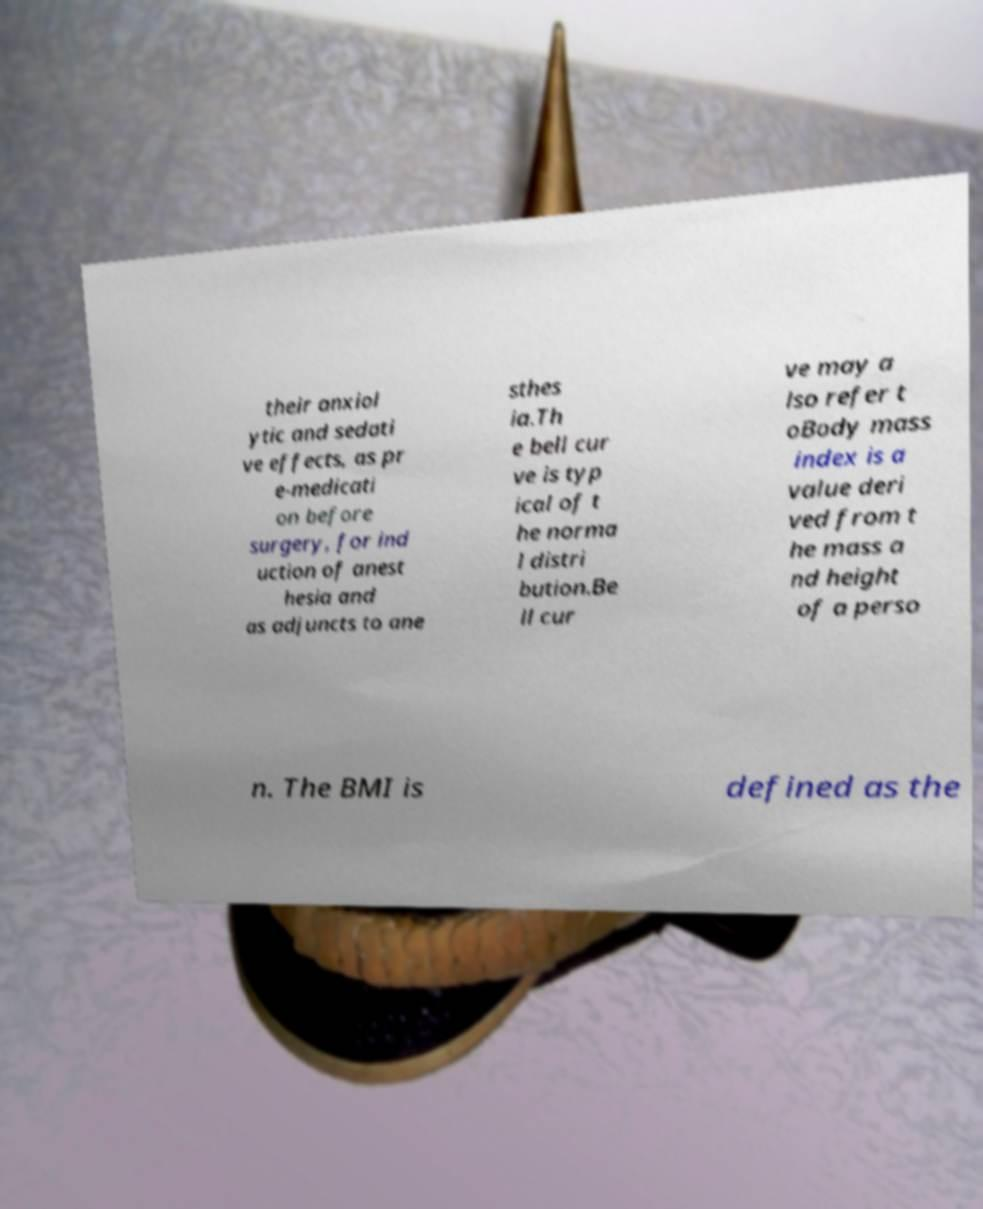Please read and relay the text visible in this image. What does it say? their anxiol ytic and sedati ve effects, as pr e-medicati on before surgery, for ind uction of anest hesia and as adjuncts to ane sthes ia.Th e bell cur ve is typ ical of t he norma l distri bution.Be ll cur ve may a lso refer t oBody mass index is a value deri ved from t he mass a nd height of a perso n. The BMI is defined as the 